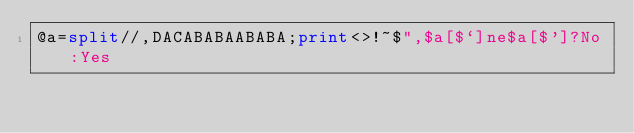Convert code to text. <code><loc_0><loc_0><loc_500><loc_500><_Perl_>@a=split//,DACABABAABABA;print<>!~$",$a[$`]ne$a[$']?No:Yes</code> 